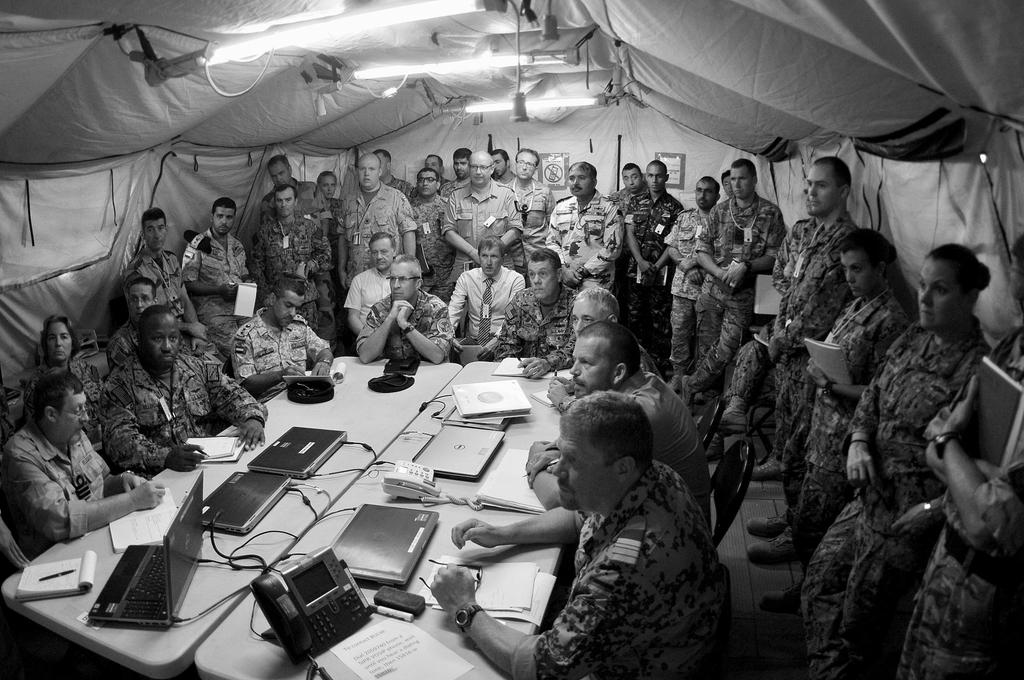What type of shelter is visible in the image? There is a tent in the image. What can be seen illuminating the area in the image? There are lights in the image. What are the people in the image wearing? The group of people in the image are wearing army dresses. What objects are present on the tables in the image? On the tables, there are laptops, phones, papers, books, and pens. What is the condition of the ball in the image? There is no ball present in the image. What does the father in the image say about the army dresses? There is no father or dialogue present in the image. 